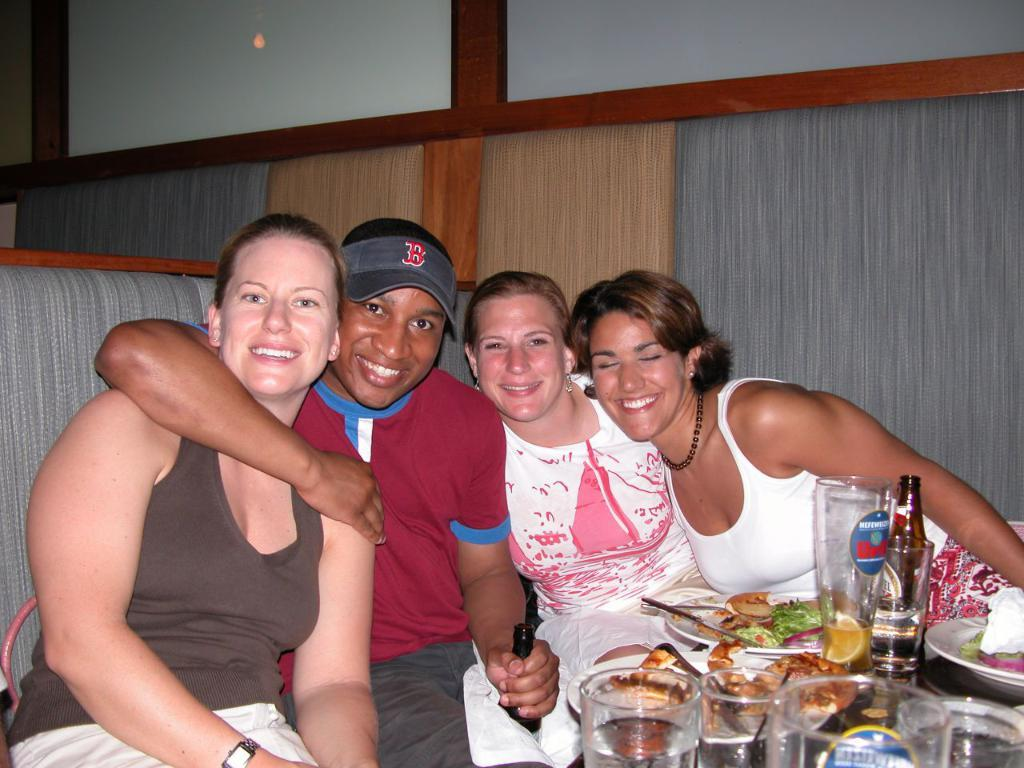How many people are in the image? There are four persons in the image. What are the four persons doing in the image? The four persons are posing for a camera. What expressions do the four persons have in the image? The four persons are smiling in the image. What objects can be seen in the image related to serving or consuming food? There are glasses, bottles, plates, spoons, and food in the image. What color is the shirt of the person who is taking a bite out of the food in the image? There is no person taking a bite out of the food in the image; the four persons are posing for a camera and smiling. 